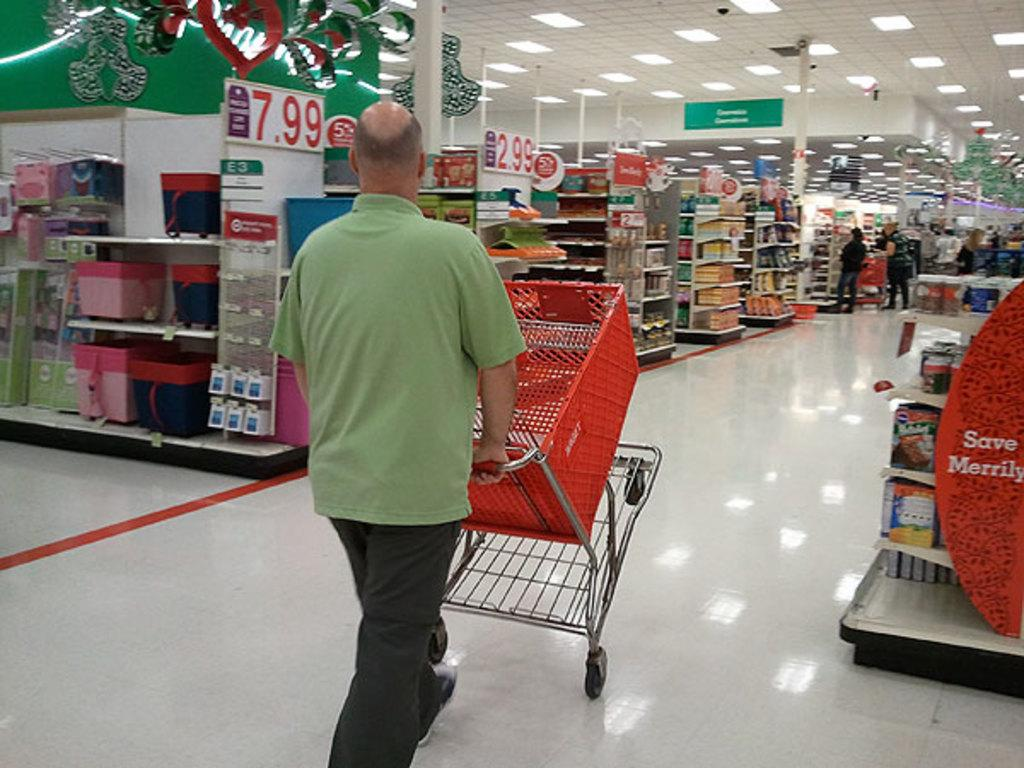<image>
Relay a brief, clear account of the picture shown. Person in a store next to a red sign that says Save Merrily. 